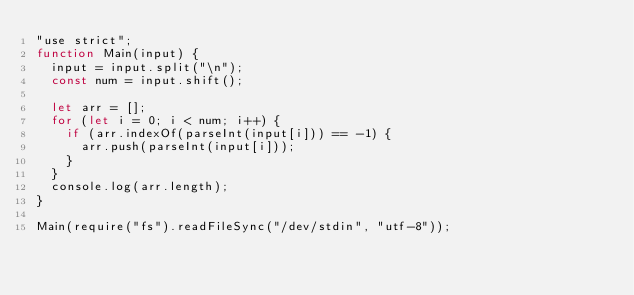<code> <loc_0><loc_0><loc_500><loc_500><_JavaScript_>"use strict";
function Main(input) {
  input = input.split("\n");
  const num = input.shift();

  let arr = [];
  for (let i = 0; i < num; i++) {
    if (arr.indexOf(parseInt(input[i])) == -1) {
      arr.push(parseInt(input[i]));
    }
  }
  console.log(arr.length);
}

Main(require("fs").readFileSync("/dev/stdin", "utf-8"));
</code> 